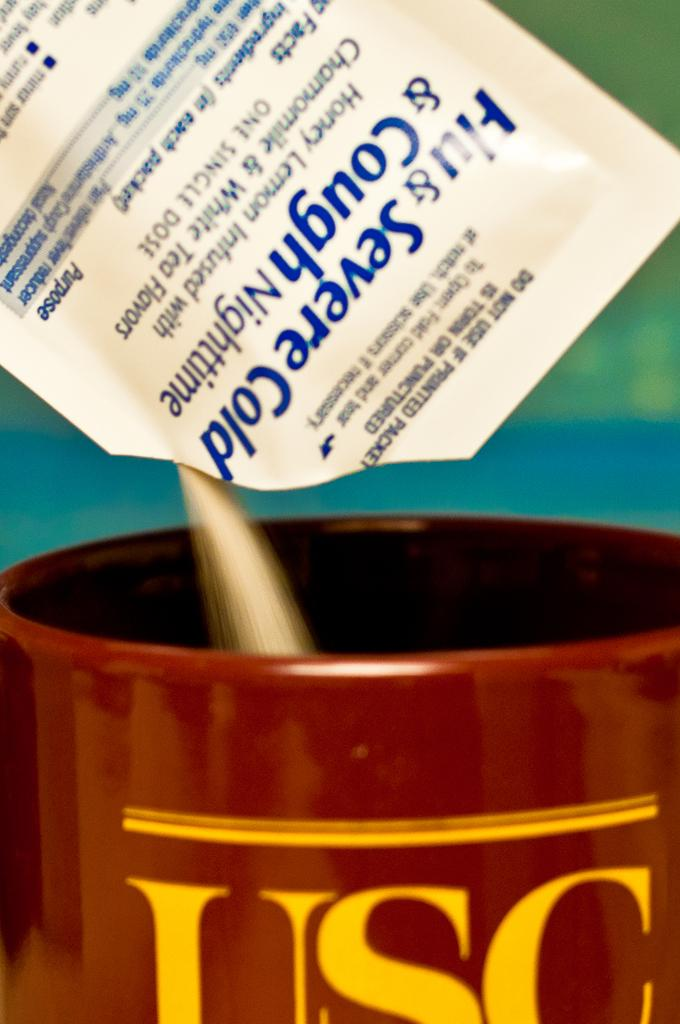What object is present in the image that can hold liquids? There is a cup in the image. What color is the cup? The cup is brown in color. What is happening in the image involving a packet? Powder is falling from a packet in the image. What month is depicted in the image? There is no month depicted in the image; it only shows a cup and powder falling from a packet. Is there a fan visible in the image? There is no fan present in the image. 